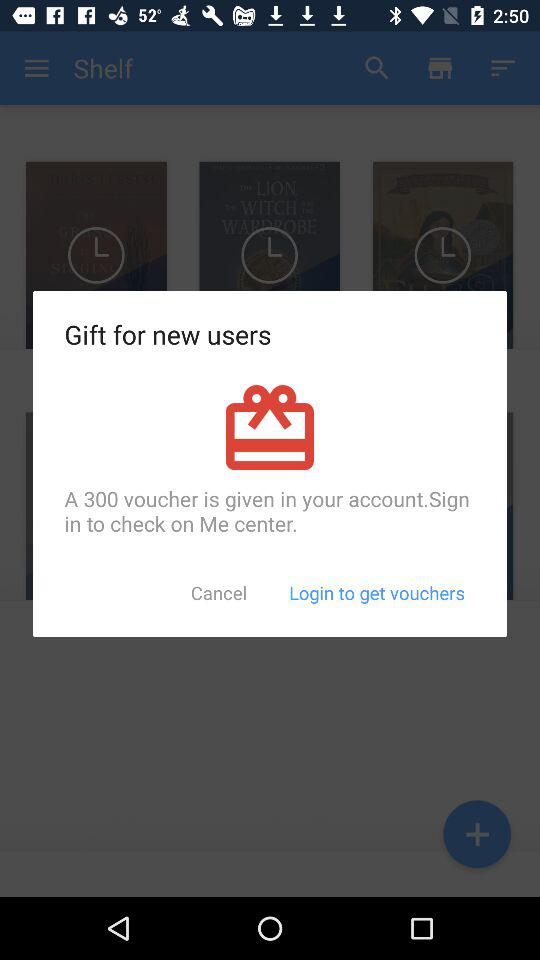How much money is the voucher worth?
Answer the question using a single word or phrase. 300 